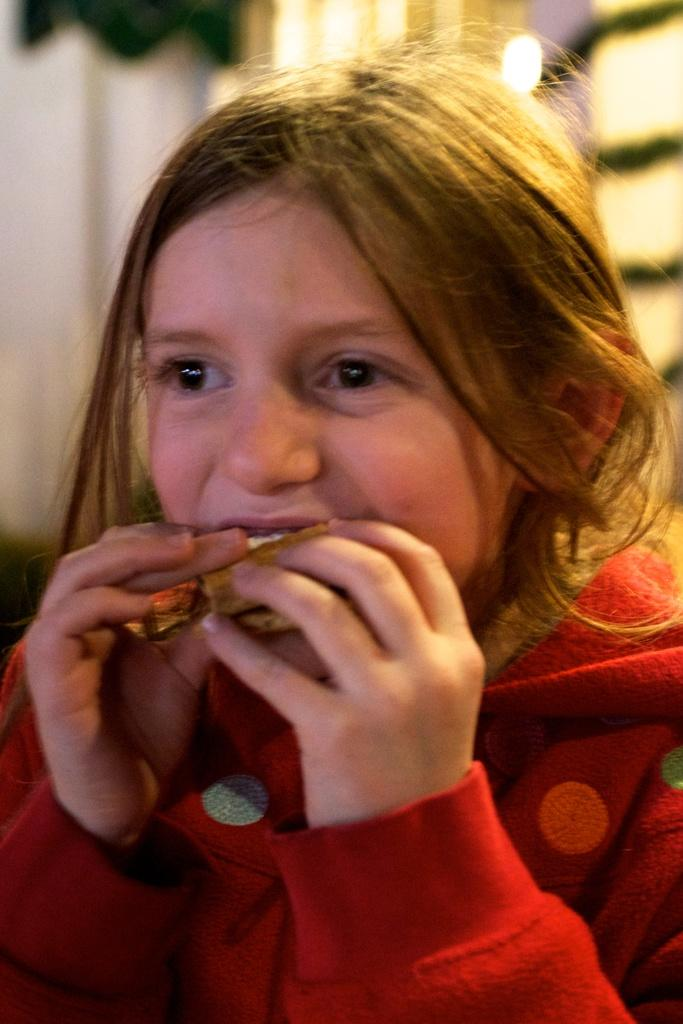What can be observed about the background of the image? The background portion of the picture is blurred. Who is the main subject in the image? There is a girl in the image. What is the girl doing in the image? The girl is having food. What type of tin can be seen in the image? There is no tin present in the image. How many clouds are visible in the image? There is no reference to clouds in the image, so it's not possible to determine how many clouds might be visible. 